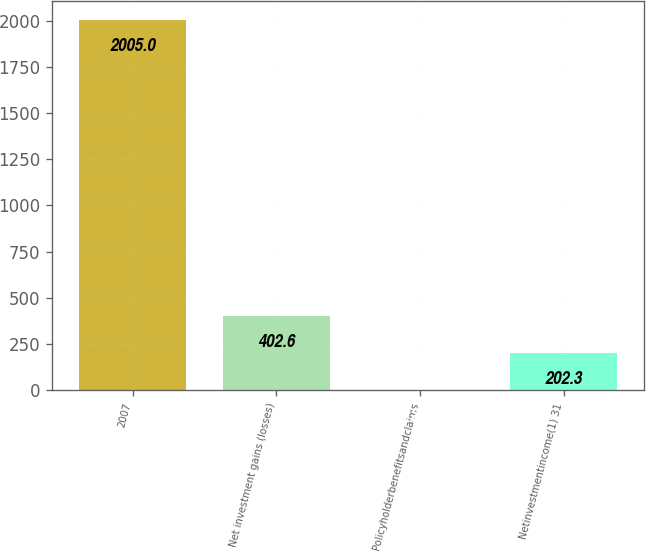Convert chart. <chart><loc_0><loc_0><loc_500><loc_500><bar_chart><fcel>2007<fcel>Net investment gains (losses)<fcel>Policyholderbenefitsandclaims<fcel>Netinvestmentincome(1) 31<nl><fcel>2005<fcel>402.6<fcel>2<fcel>202.3<nl></chart> 